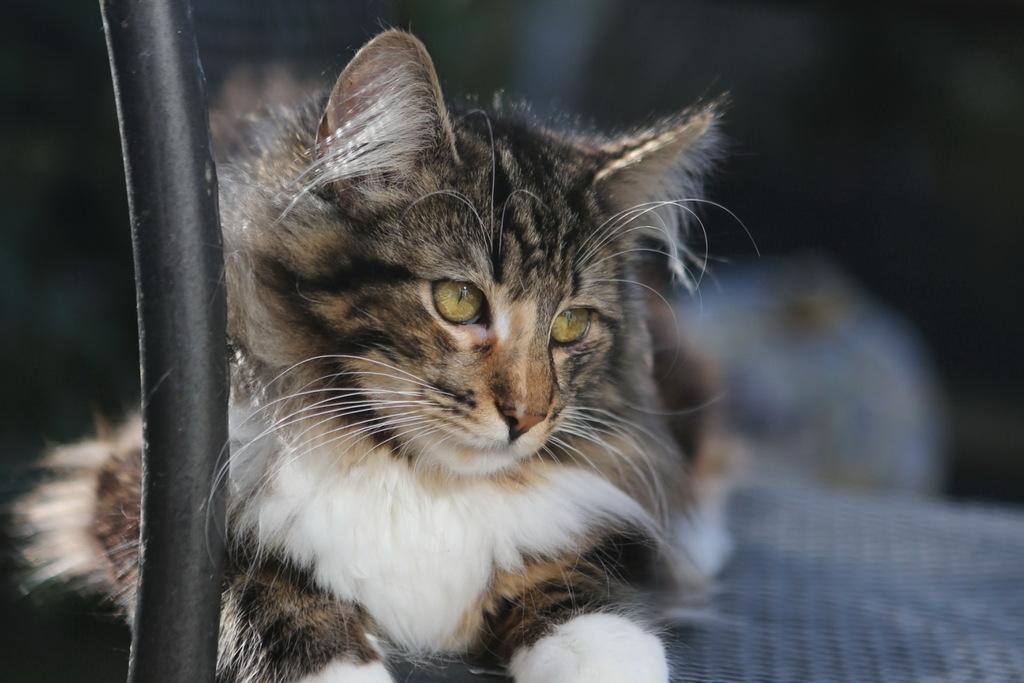In one or two sentences, can you explain what this image depicts? In this image I can see the cat in brown, black and white color. In front I can see the black color object and the blurred background. 